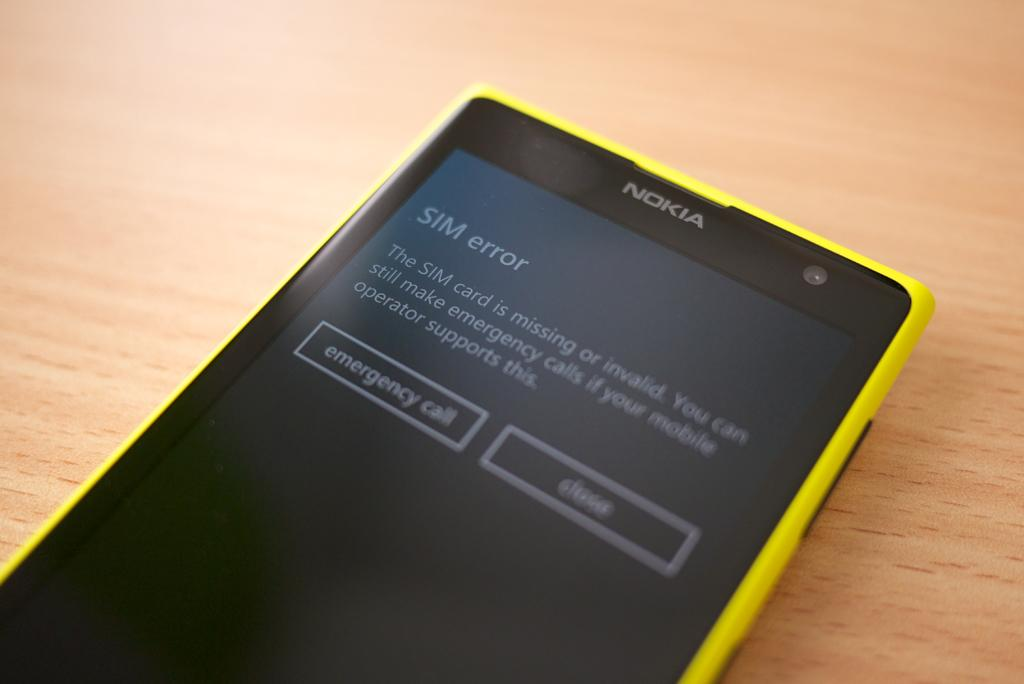<image>
Give a short and clear explanation of the subsequent image. A yellow Nokia device showing a SIM error on the screen. 